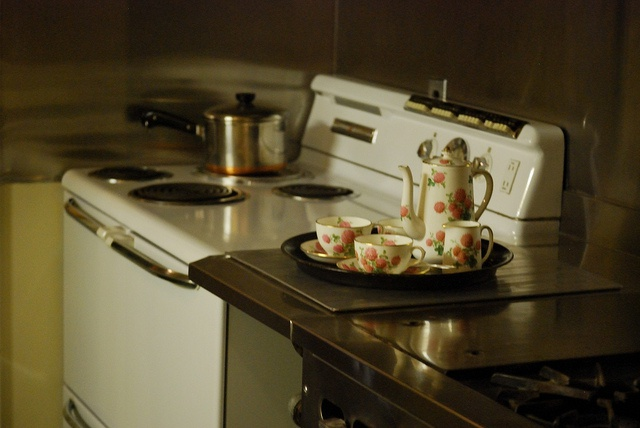Describe the objects in this image and their specific colors. I can see oven in black, tan, and olive tones, cup in black, olive, and tan tones, cup in black, olive, maroon, and tan tones, and cup in black, tan, and olive tones in this image. 